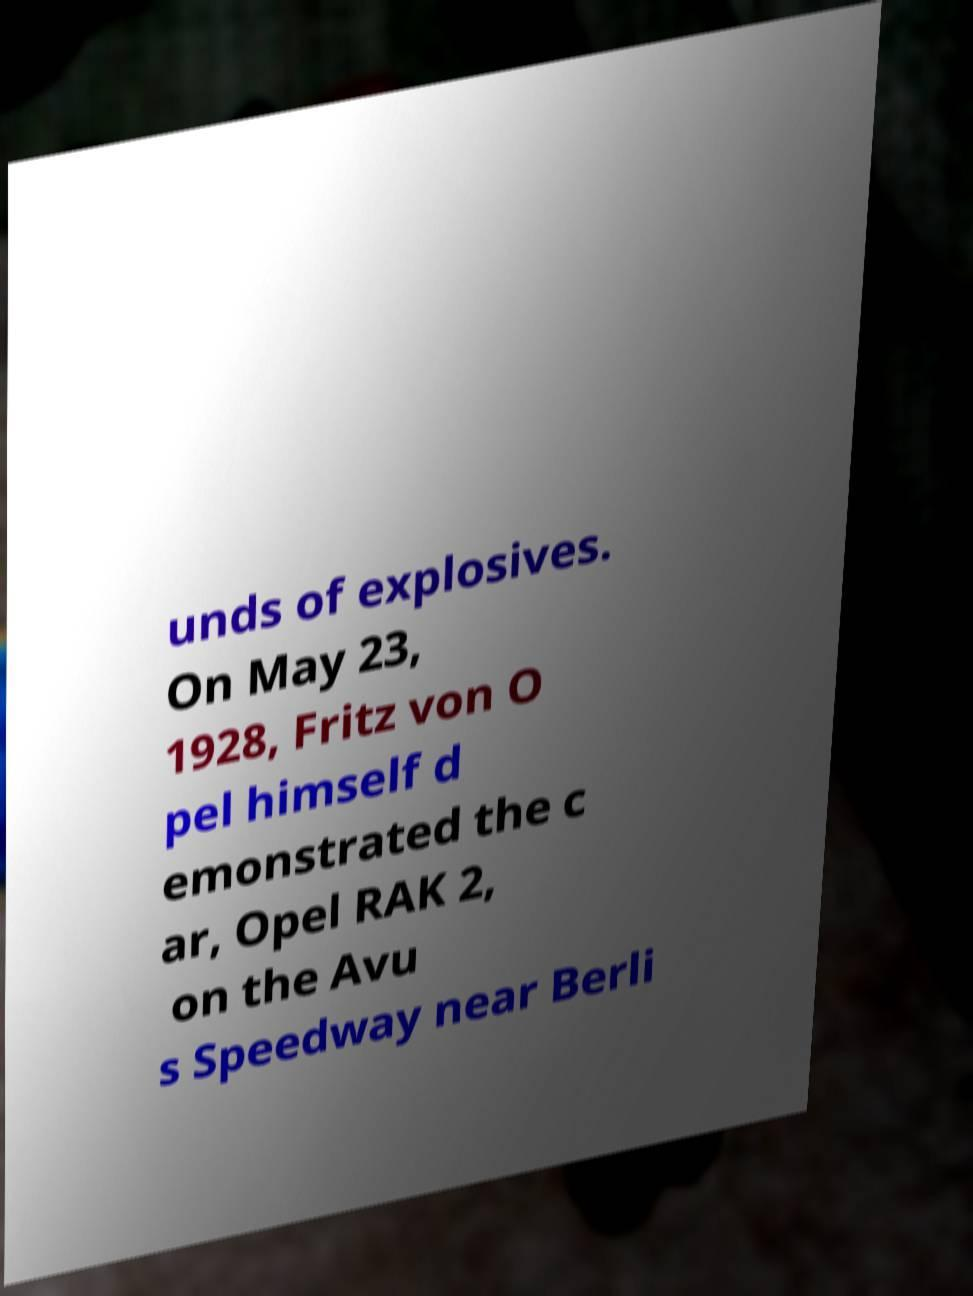Please read and relay the text visible in this image. What does it say? unds of explosives. On May 23, 1928, Fritz von O pel himself d emonstrated the c ar, Opel RAK 2, on the Avu s Speedway near Berli 